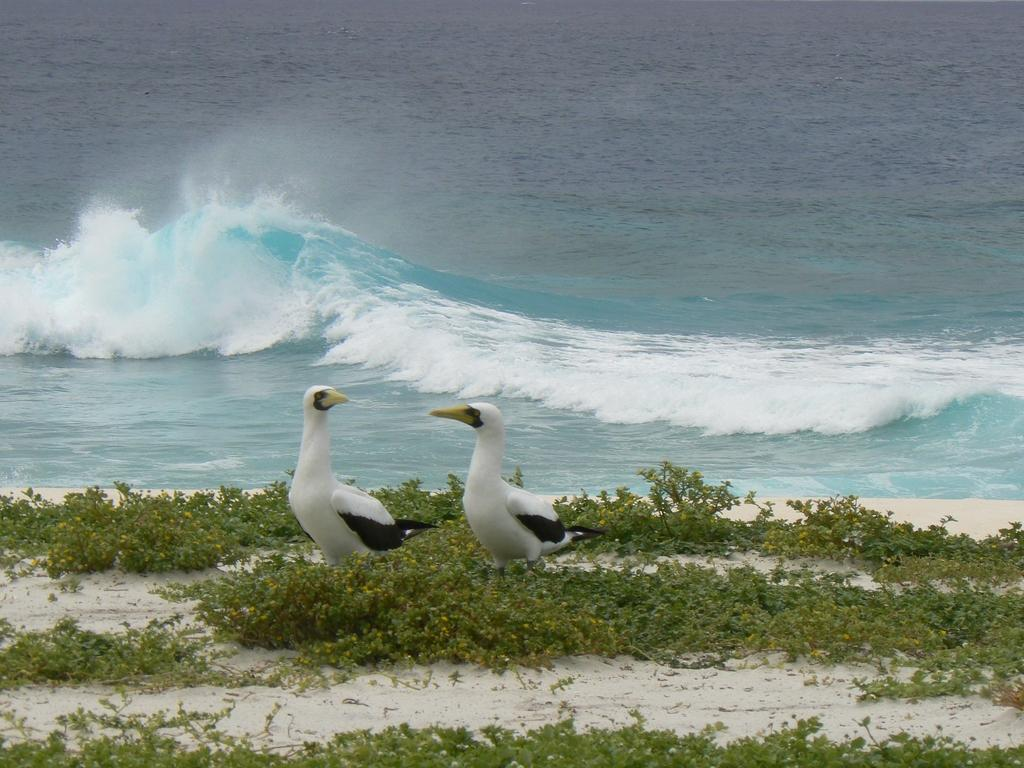How many birds are in the image? There are two birds in the image. What are the colors of the birds? One bird is white in color, and the other bird is black in color. What type of terrain is visible in the image? There is sand, grass, and water visible in the image. What type of polish is the bird using to clean its feathers in the image? There is no indication in the image that the bird is using any polish to clean its feathers. 